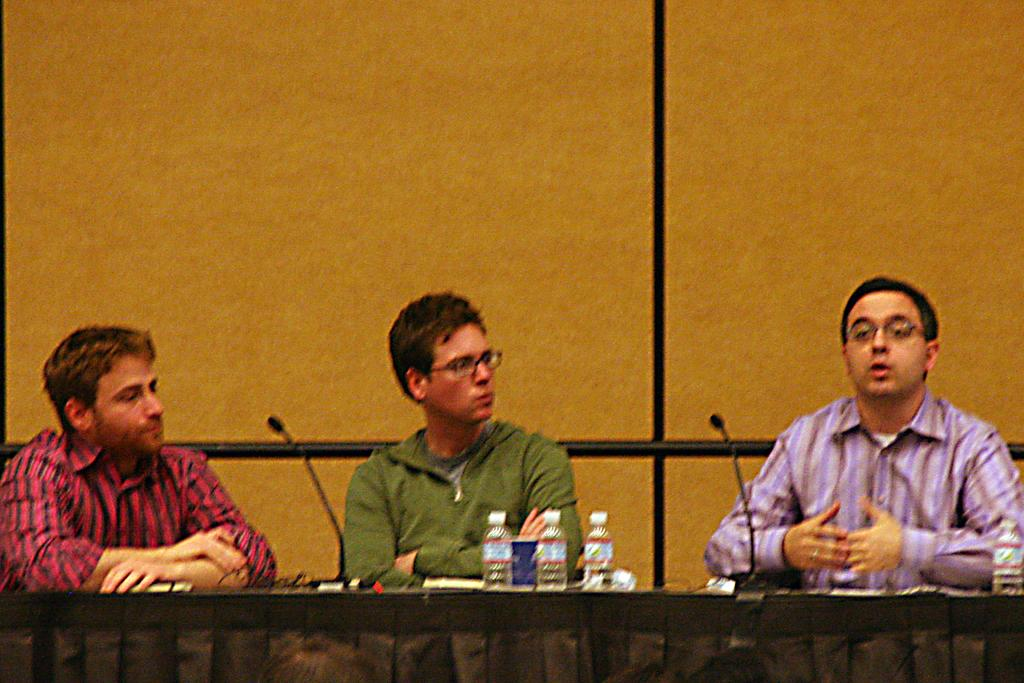How many people are in the image? There are three persons in the image. What are the persons doing in the image? The persons are sitting before a table. What objects can be seen on the table? There are bottles and miles on the table. What is behind the persons in the image? There is a wall behind the persons. What is the appearance of one of the persons? One person is wearing a green jacket and has spectacles. What type of hole can be seen in the statement made by the person wearing the green jacket? There is no hole or statement present in the image; it only shows three persons sitting before a table with bottles and miles. 